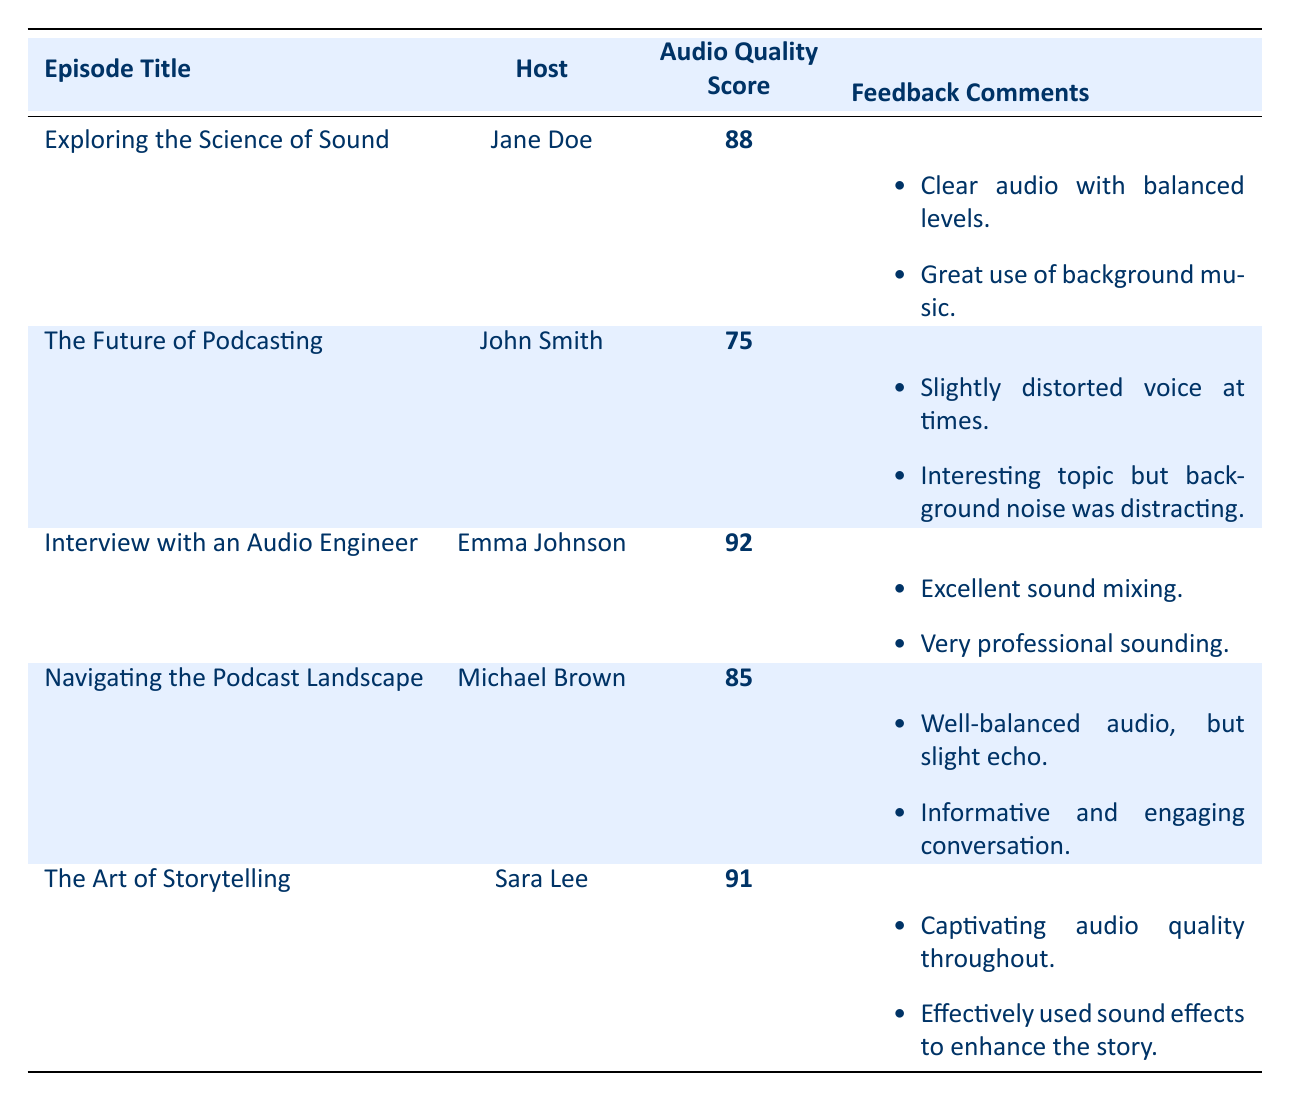What is the audio quality score for "Interview with an Audio Engineer"? The table lists the audio quality scores for each episode, and "Interview with an Audio Engineer" has a score of 92.
Answer: 92 Which episode has the highest audio quality score? By comparing the audio quality scores in the table, "Interview with an Audio Engineer" has the highest score of 92.
Answer: Interview with an Audio Engineer What is the average audio quality score across all episodes? To find the average, sum the audio quality scores: 88 + 75 + 92 + 85 + 91 = 431. There are 5 episodes, so the average is 431/5 = 86.2.
Answer: 86.2 Did any episode receive feedback about background noise? The feedback comments for "The Future of Podcasting" mention "background noise was distracting."
Answer: Yes How much higher is the audio quality score of "The Art of Storytelling" compared to "The Future of Podcasting"? "The Art of Storytelling" has a score of 91 and "The Future of Podcasting" has a score of 75. The difference is 91 - 75 = 16.
Answer: 16 How many episodes scored above 90 in audio quality? The table indicates two episodes, "Interview with an Audio Engineer" (score 92) and "The Art of Storytelling" (score 91), scored above 90.
Answer: 2 What percentage of episodes received a listener engagement score of 90 or above? There are 5 episodes and 3 of them ("Exploring the Science of Sound," "Interview with an Audio Engineer," and "The Art of Storytelling") received scores of 90 or above. To find the percentage, calculate (3/5)*100 = 60%.
Answer: 60% Which host had the lowest audio quality score and what was that score? The host with the lowest audio quality score is John Smith from "The Future of Podcasting," with a score of 75.
Answer: John Smith, 75 Is there any episode where the audio quality score is the same as the listener engagement score? Comparing the scores, no episode has the same audio quality score as the listener engagement score; they all differ.
Answer: No In which episode did listeners comment on the use of sound effects? Feedback for "The Art of Storytelling" mentions "effectively used sound effects to enhance the story."
Answer: The Art of Storytelling 